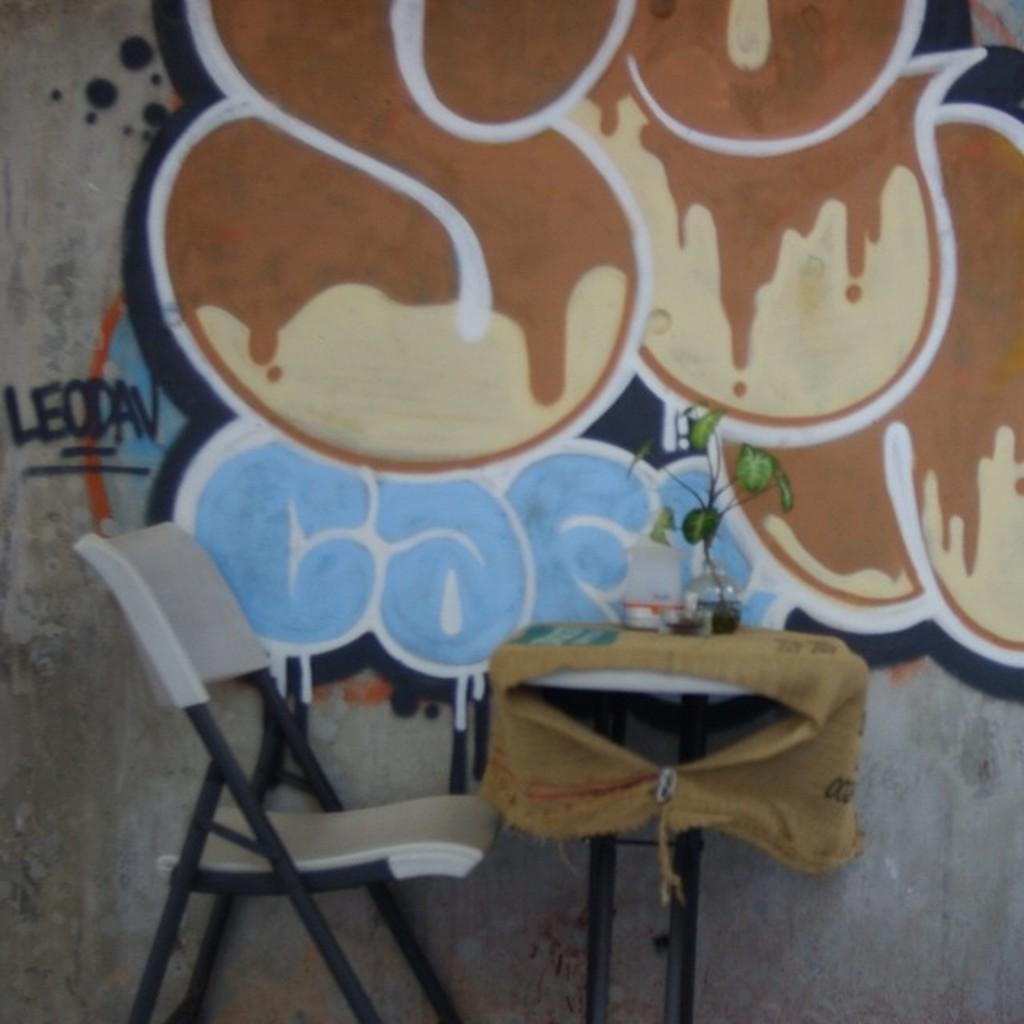What type of furniture is present in the image? There is a chair and a table in the image. How is the table decorated or covered? The table is covered with cloth. What can be found on the table? There is a potted plant and an object on the table. What is hanging on the wall in the image? There is a painting on the wall. What type of substance is leaking from the bucket in the image? There is no bucket present in the image, so it is not possible to determine if any substance is leaking. 